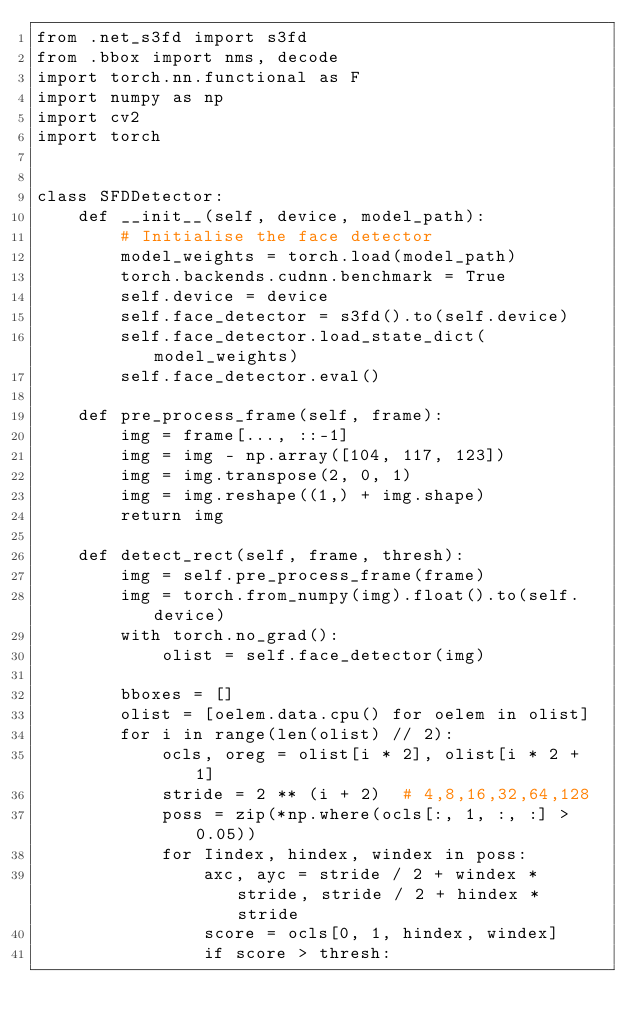<code> <loc_0><loc_0><loc_500><loc_500><_Python_>from .net_s3fd import s3fd
from .bbox import nms, decode
import torch.nn.functional as F
import numpy as np
import cv2
import torch


class SFDDetector:
    def __init__(self, device, model_path):
        # Initialise the face detector
        model_weights = torch.load(model_path)
        torch.backends.cudnn.benchmark = True
        self.device = device
        self.face_detector = s3fd().to(self.device)
        self.face_detector.load_state_dict(model_weights)
        self.face_detector.eval()

    def pre_process_frame(self, frame):
        img = frame[..., ::-1]
        img = img - np.array([104, 117, 123])
        img = img.transpose(2, 0, 1)
        img = img.reshape((1,) + img.shape)
        return img

    def detect_rect(self, frame, thresh):
        img = self.pre_process_frame(frame)
        img = torch.from_numpy(img).float().to(self.device)
        with torch.no_grad():
            olist = self.face_detector(img)

        bboxes = []
        olist = [oelem.data.cpu() for oelem in olist]
        for i in range(len(olist) // 2):
            ocls, oreg = olist[i * 2], olist[i * 2 + 1]
            stride = 2 ** (i + 2)  # 4,8,16,32,64,128
            poss = zip(*np.where(ocls[:, 1, :, :] > 0.05))
            for Iindex, hindex, windex in poss:
                axc, ayc = stride / 2 + windex * stride, stride / 2 + hindex * stride
                score = ocls[0, 1, hindex, windex]
                if score > thresh:</code> 